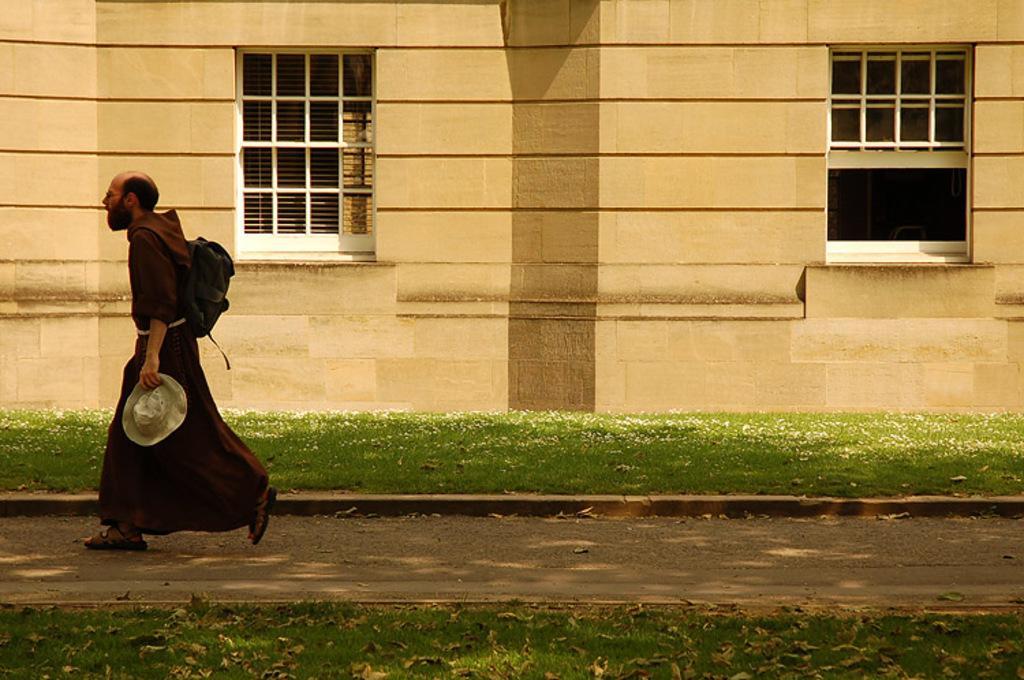Could you give a brief overview of what you see in this image? On the left side, we see a man in brown dress who is wearing a bag is walking on the pavement. He is holding a hat in his hand. On either side of the pavement, we see grass and dry leaves. In the background, we see a building or a wall and we even see the windows. 